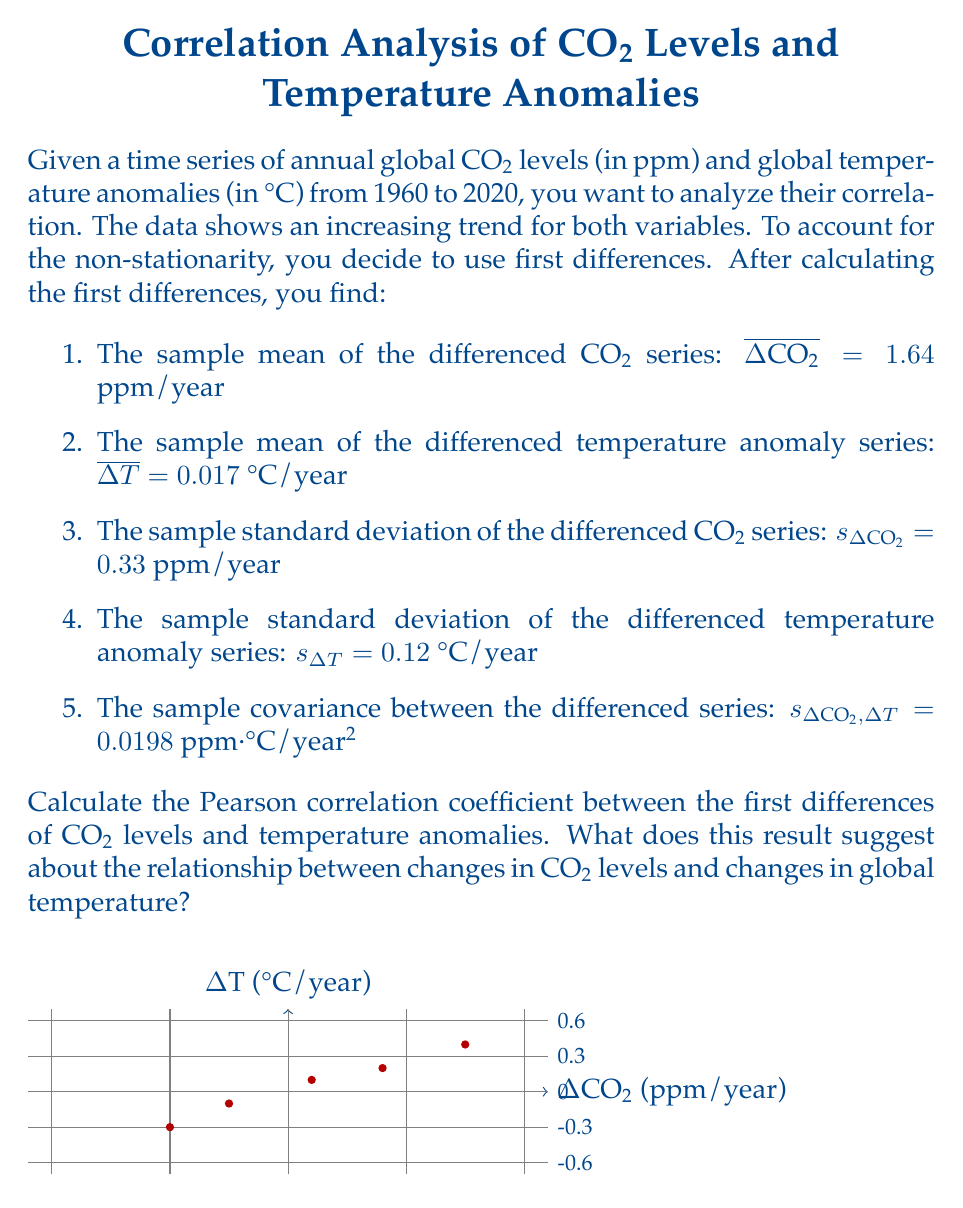Can you solve this math problem? To calculate the Pearson correlation coefficient between the first differences of CO2 levels and temperature anomalies, we'll use the formula:

$$r = \frac{Cov(\Delta CO2, \Delta T)}{s_{\Delta CO2} \cdot s_{\Delta T}}$$

Where:
- $Cov(\Delta CO2, \Delta T)$ is the covariance between the differenced series
- $s_{\Delta CO2}$ is the standard deviation of the differenced CO2 series
- $s_{\Delta T}$ is the standard deviation of the differenced temperature anomaly series

We're given:
- $s_{\Delta CO2, \Delta T} = 0.0198$ ppm·°C/year² (covariance)
- $s_{\Delta CO2} = 0.33$ ppm/year
- $s_{\Delta T} = 0.12$ °C/year

Let's substitute these values into the formula:

$$r = \frac{0.0198}{0.33 \cdot 0.12}$$

$$r = \frac{0.0198}{0.0396}$$

$$r = 0.5$$

The Pearson correlation coefficient is 0.5, which indicates a moderate positive correlation between the first differences of CO2 levels and temperature anomalies.

This result suggests that there is a positive relationship between changes in CO2 levels and changes in global temperature. Specifically:

1. The positive value indicates that as the change in CO2 levels increases, the change in temperature tends to increase as well.
2. The magnitude of 0.5 suggests a moderate strength of this relationship. It's not a perfect correlation (which would be 1), but it's also not negligible.
3. This correlation in the first differences implies that year-to-year changes in CO2 levels are associated with year-to-year changes in global temperature, even after removing the long-term trend.

However, it's important to note that correlation does not imply causation. While this result is consistent with the greenhouse effect theory, other factors and more complex analyses would be needed to establish a causal relationship between CO2 levels and global temperature changes.
Answer: $r = 0.5$ 